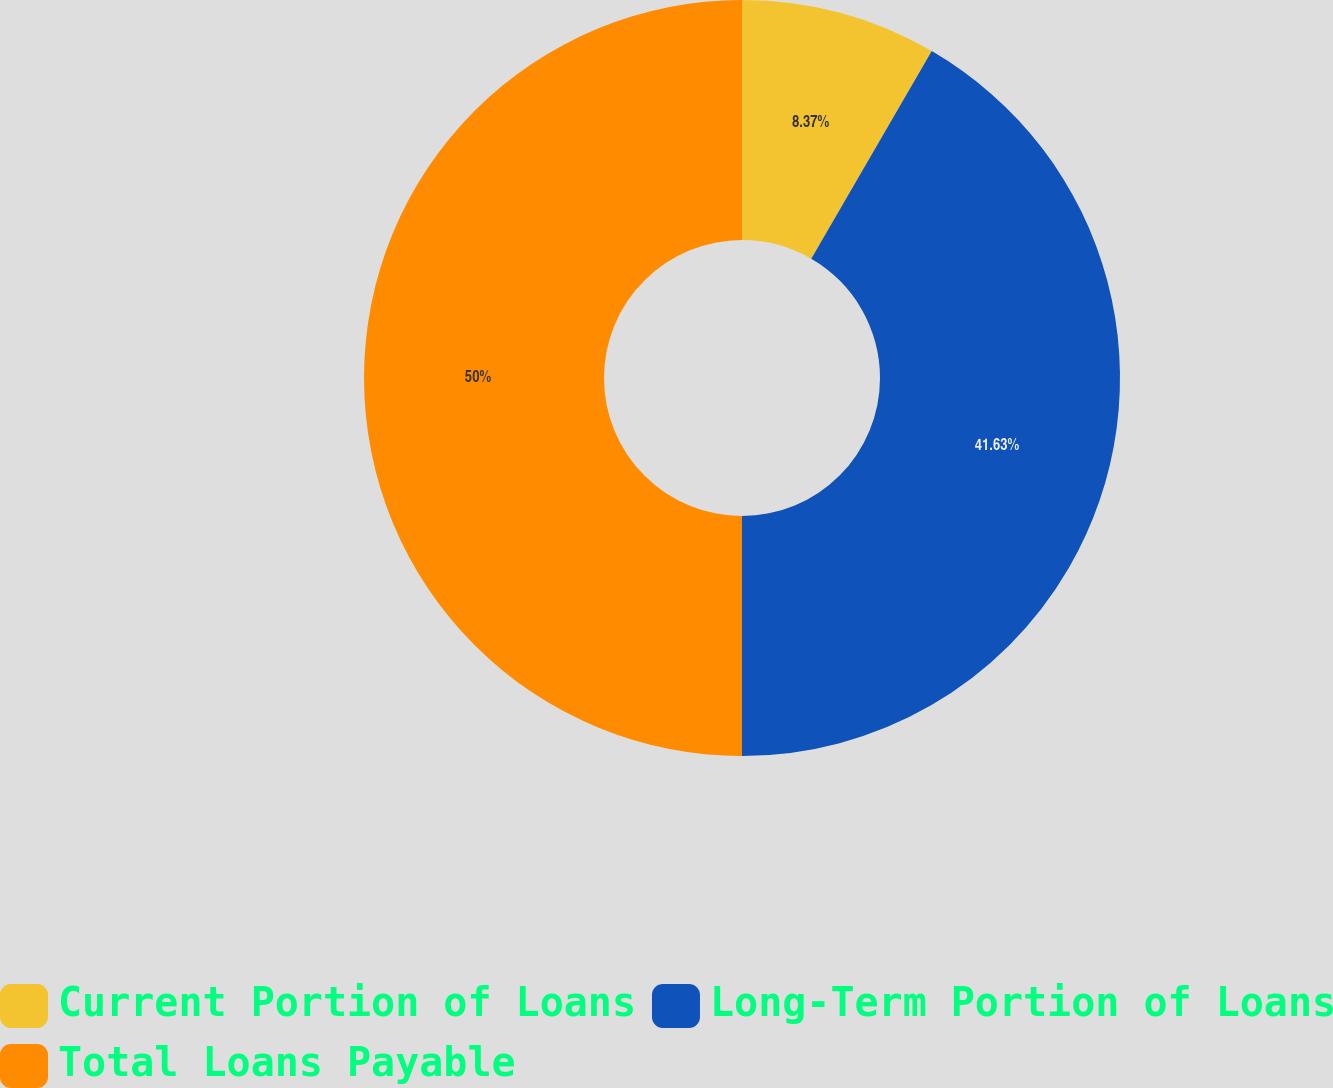Convert chart to OTSL. <chart><loc_0><loc_0><loc_500><loc_500><pie_chart><fcel>Current Portion of Loans<fcel>Long-Term Portion of Loans<fcel>Total Loans Payable<nl><fcel>8.37%<fcel>41.63%<fcel>50.0%<nl></chart> 